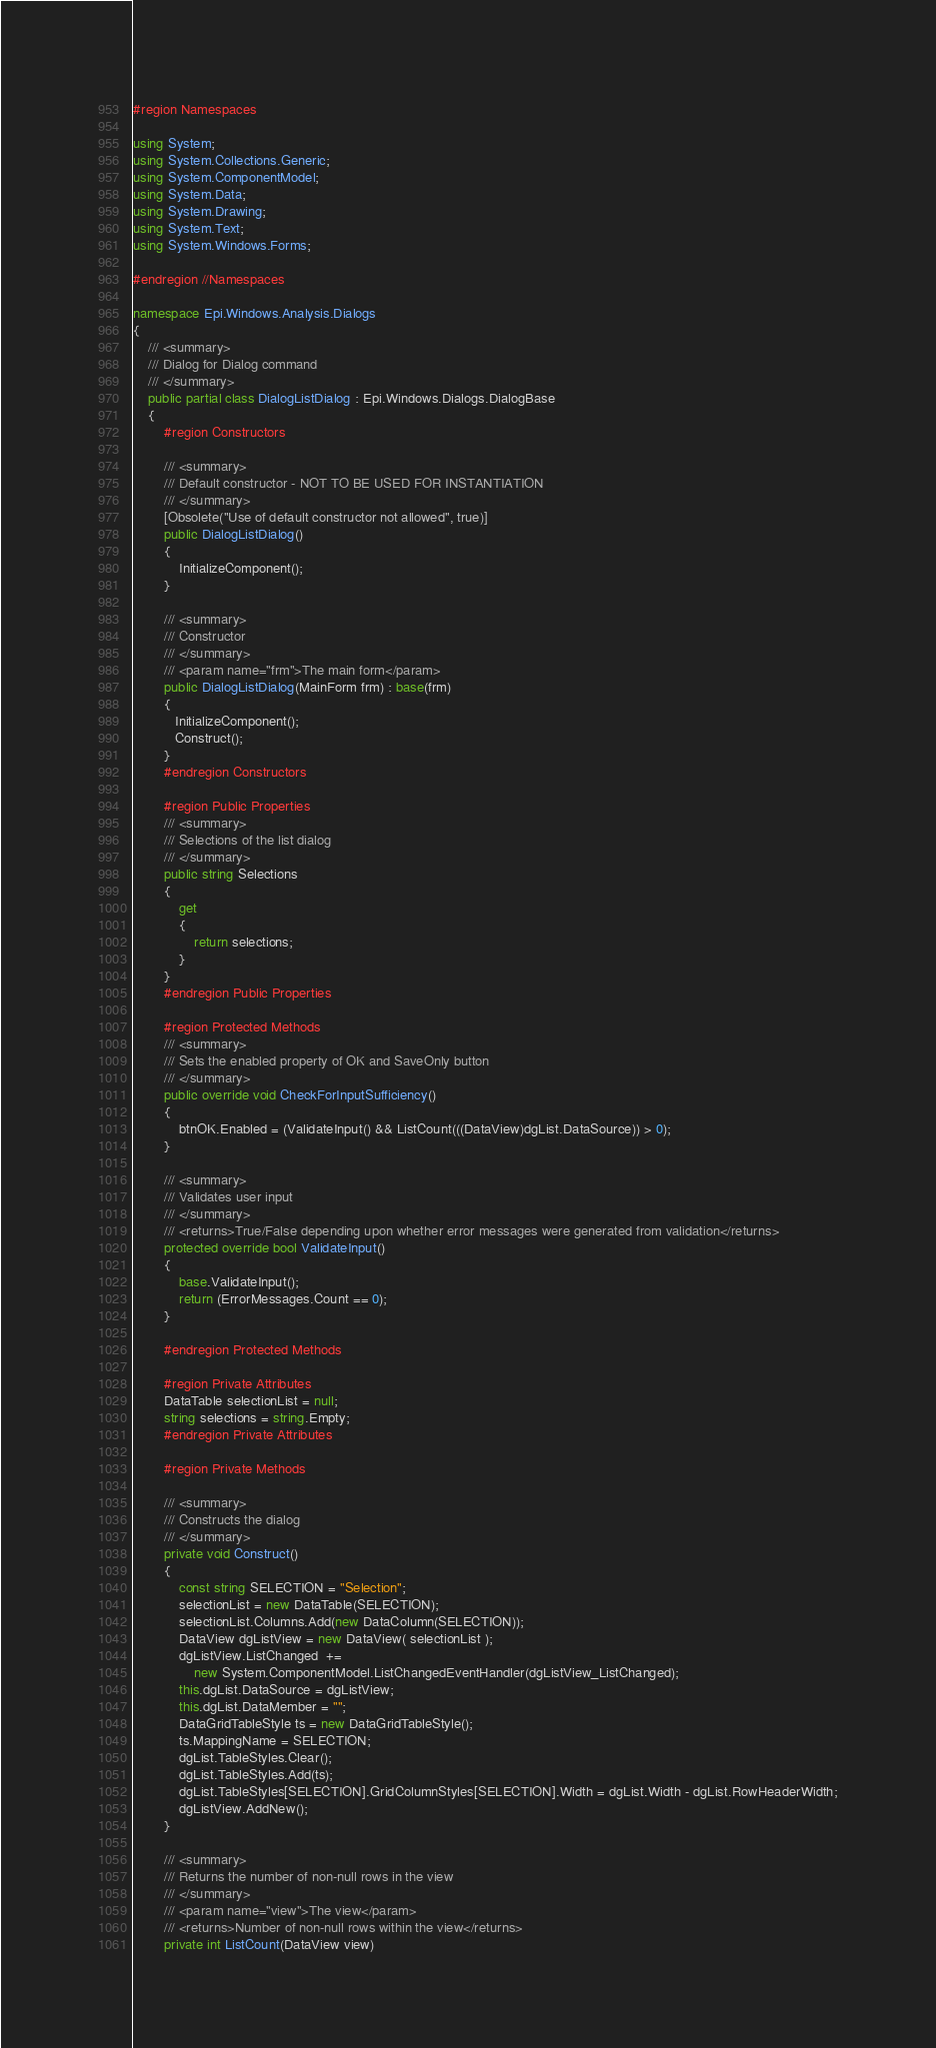Convert code to text. <code><loc_0><loc_0><loc_500><loc_500><_C#_>#region Namespaces

using System;
using System.Collections.Generic;
using System.ComponentModel;
using System.Data;
using System.Drawing;
using System.Text;
using System.Windows.Forms;

#endregion //Namespaces

namespace Epi.Windows.Analysis.Dialogs
{
	/// <summary>
	/// Dialog for Dialog command
	/// </summary>
    public partial class DialogListDialog : Epi.Windows.Dialogs.DialogBase
    {
        #region Constructors

        /// <summary>
        /// Default constructor - NOT TO BE USED FOR INSTANTIATION
        /// </summary>
        [Obsolete("Use of default constructor not allowed", true)]
        public DialogListDialog()
        {
            InitializeComponent();
        }

        /// <summary>
        /// Constructor
        /// </summary>
        /// <param name="frm">The main form</param>
        public DialogListDialog(MainForm frm) : base(frm)
        {
           InitializeComponent();
           Construct();
        }
        #endregion Constructors

        #region Public Properties
        /// <summary>
        /// Selections of the list dialog
        /// </summary>
        public string Selections
        {
            get
            {
                return selections;
            }
        }
        #endregion Public Properties

        #region Protected Methods
        /// <summary>
        /// Sets the enabled property of OK and SaveOnly button
        /// </summary>		
        public override void CheckForInputSufficiency()
        {
            btnOK.Enabled = (ValidateInput() && ListCount(((DataView)dgList.DataSource)) > 0);
        }

        /// <summary>
        /// Validates user input
        /// </summary>
        /// <returns>True/False depending upon whether error messages were generated from validation</returns>
        protected override bool ValidateInput()
        {
            base.ValidateInput();
            return (ErrorMessages.Count == 0);
        }

        #endregion Protected Methods

        #region Private Attributes
        DataTable selectionList = null;
        string selections = string.Empty;
        #endregion Private Attributes

        #region Private Methods

        /// <summary>
        /// Constructs the dialog
        /// </summary>
        private void Construct()
        {
            const string SELECTION = "Selection";
            selectionList = new DataTable(SELECTION);
            selectionList.Columns.Add(new DataColumn(SELECTION));
            DataView dgListView = new DataView( selectionList );
            dgListView.ListChanged  += 
                new System.ComponentModel.ListChangedEventHandler(dgListView_ListChanged);
            this.dgList.DataSource = dgListView;
            this.dgList.DataMember = "";
            DataGridTableStyle ts = new DataGridTableStyle();
            ts.MappingName = SELECTION;
            dgList.TableStyles.Clear();
            dgList.TableStyles.Add(ts);
            dgList.TableStyles[SELECTION].GridColumnStyles[SELECTION].Width = dgList.Width - dgList.RowHeaderWidth;
            dgListView.AddNew();
        }

        /// <summary>
        /// Returns the number of non-null rows in the view
        /// </summary>
        /// <param name="view">The view</param>
        /// <returns>Number of non-null rows within the view</returns>
        private int ListCount(DataView view)</code> 